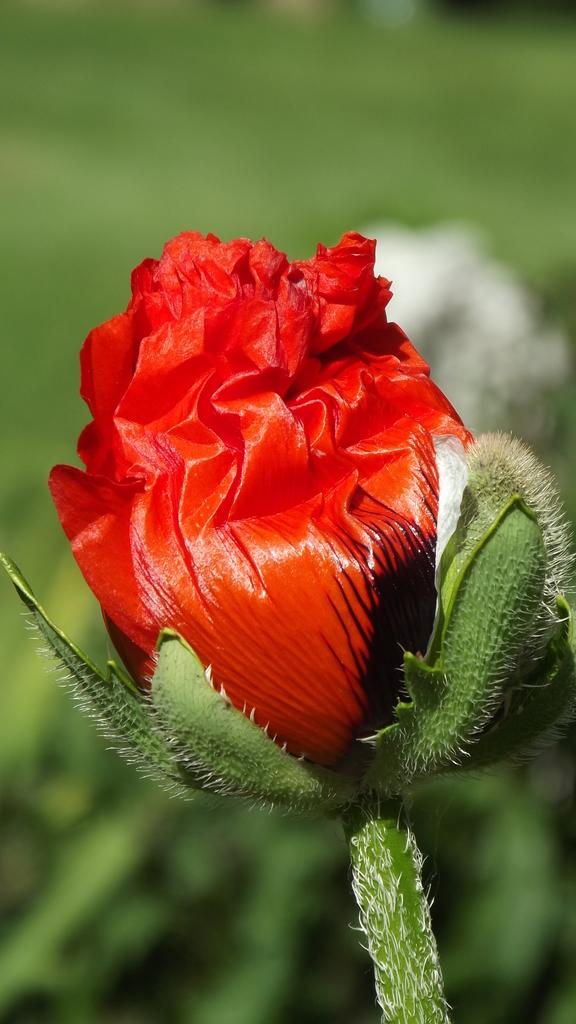What is the main subject of the image? The main subject of the image is a flower. What is the color of the flower? The flower is red in color. Can you describe the background of the image? The background of the image is blurred. What role does the flower play in society in the image? The image does not depict any societal context or purpose for the flower, so it cannot be determined from the picture. What type of monkey can be seen interacting with the flower in the image? There is no monkey present in the image; it features only a red flower and a blurred background. 